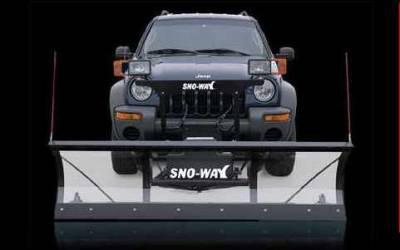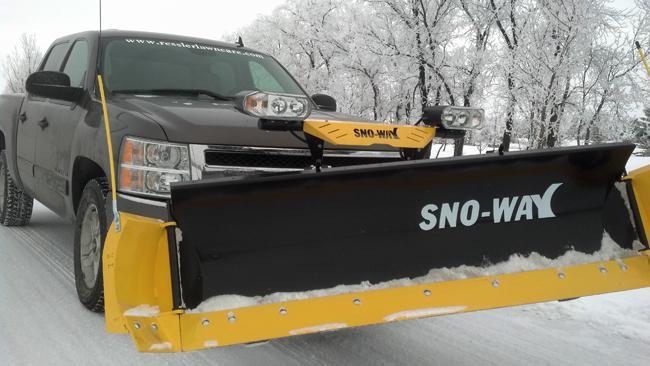The first image is the image on the left, the second image is the image on the right. Analyze the images presented: Is the assertion "The right image contains a truck attached to a snow plow that has a yellow lower border." valid? Answer yes or no. Yes. The first image is the image on the left, the second image is the image on the right. Evaluate the accuracy of this statement regarding the images: "All of the plows are black with a yellow border.". Is it true? Answer yes or no. No. 